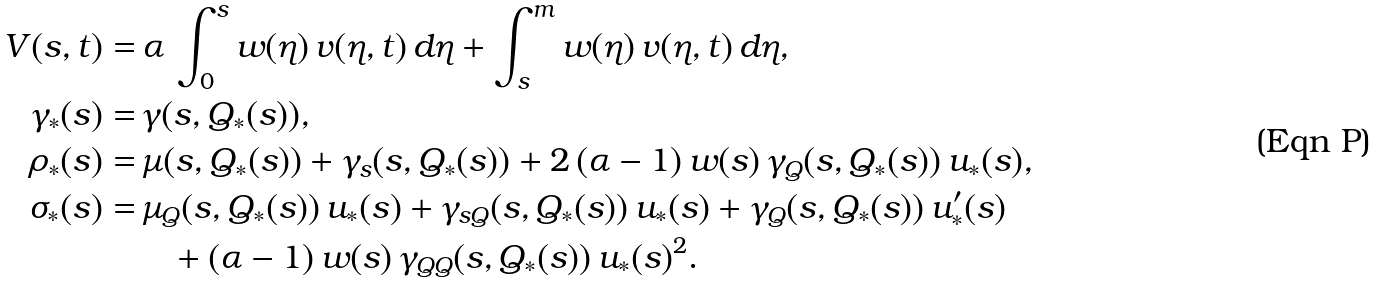<formula> <loc_0><loc_0><loc_500><loc_500>V ( s , t ) = & \, \alpha \, \int _ { 0 } ^ { s } w ( \eta ) \, v ( \eta , t ) \, d \eta + \int _ { s } ^ { m } w ( \eta ) \, v ( \eta , t ) \, d \eta , \\ \gamma _ { * } ( s ) = & \, \gamma ( s , Q _ { * } ( s ) ) , \\ \rho _ { * } ( s ) = & \, \mu ( s , Q _ { * } ( s ) ) + \gamma _ { s } ( s , Q _ { * } ( s ) ) + 2 \, ( \alpha - 1 ) \, w ( s ) \, \gamma _ { Q } ( s , Q _ { * } ( s ) ) \, u _ { * } ( s ) , \\ \sigma _ { * } ( s ) = & \, \mu _ { Q } ( s , Q _ { * } ( s ) ) \, u _ { * } ( s ) + \gamma _ { s Q } ( s , Q _ { * } ( s ) ) \, u _ { * } ( s ) + \gamma _ { Q } ( s , Q _ { * } ( s ) ) \, u _ { * } ^ { \prime } ( s ) \\ & \quad + ( \alpha - 1 ) \, w ( s ) \, \gamma _ { Q Q } ( s , Q _ { * } ( s ) ) \, u _ { * } ( s ) ^ { 2 } .</formula> 